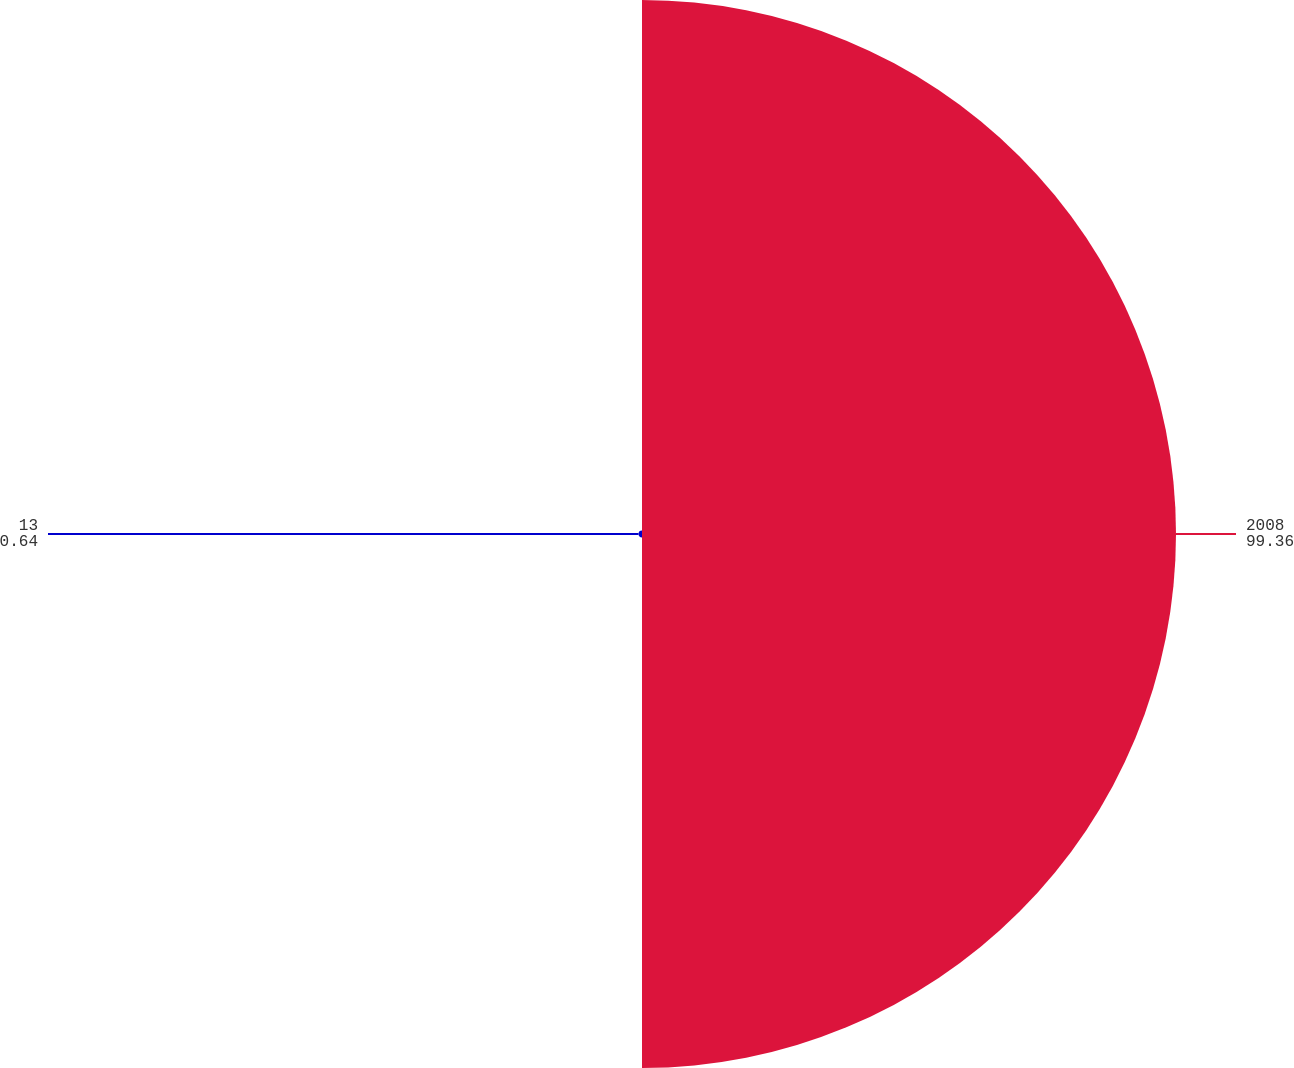Convert chart. <chart><loc_0><loc_0><loc_500><loc_500><pie_chart><fcel>2008<fcel>13<nl><fcel>99.36%<fcel>0.64%<nl></chart> 